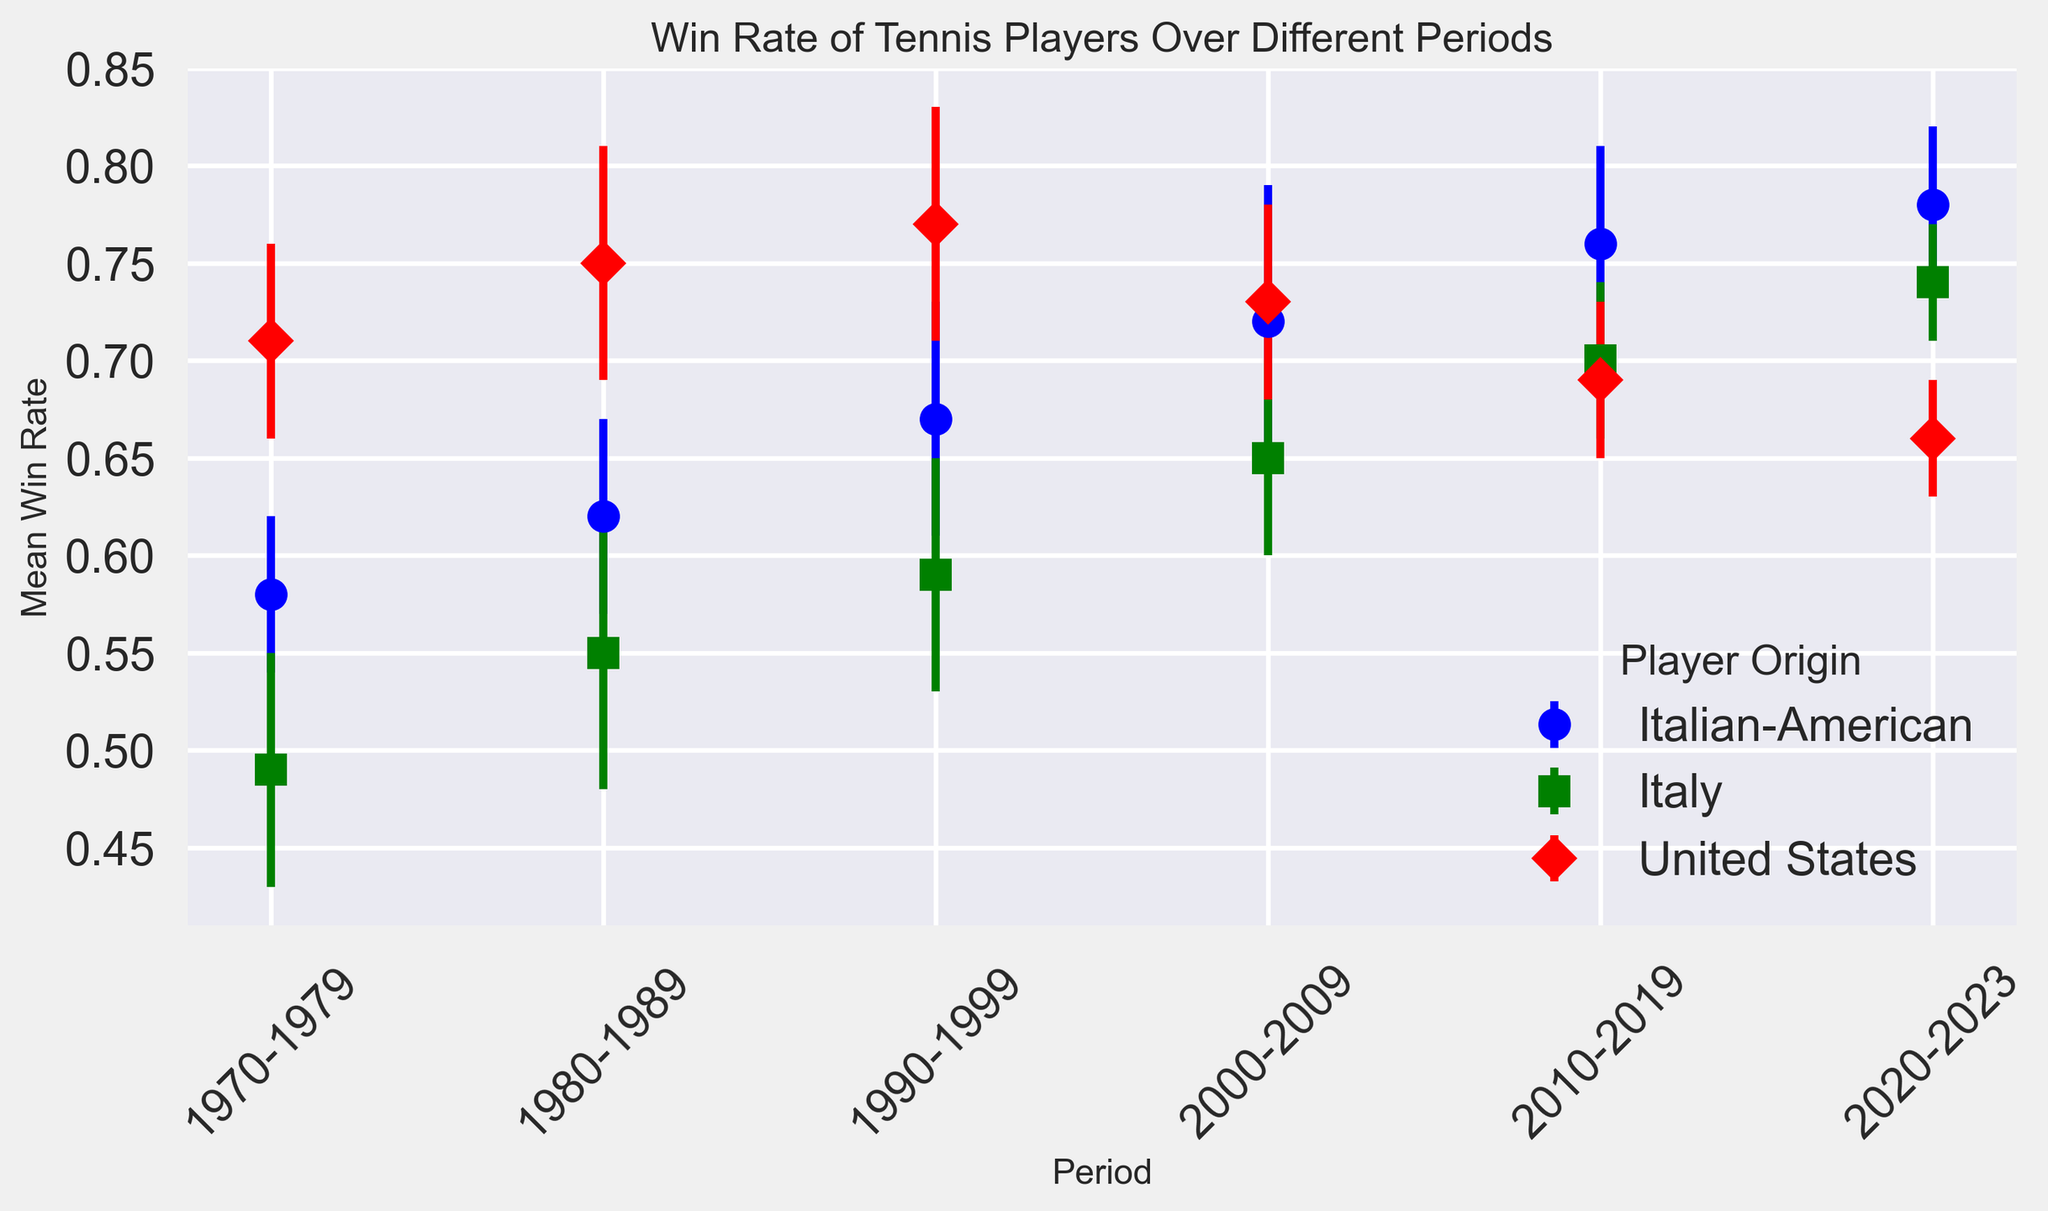Which player origin had the highest win rate in the 1970-1979 period? Look at the series of lines for each player origin and find the one that is highest in the 1970-1979 period. The United States players' line is highest at this period.
Answer: United States How did the win rate of Italian-American players change from the 1970-1979 period to the 2020-2023 period? Determine the win rate of Italian-American players in both periods and calculate the difference. The win rate increased from 0.58 to 0.78.
Answer: Increased by 0.20 Which period showed a decrease in win rate for United States players? Trace the United States players' line and identify the period where the win rate decreases. The win rate decreased between the 1990-1999 and 2000-2009 periods, and again between the 2000-2009 and 2010-2019 periods.
Answer: 2000-2009 and 2010-2019 In which period is the difference in win rate between Italian and Italian-American players the greatest? Examine the lines for Italian and Italian-American players in each period and find the period with the greatest vertical distance between them. The 2000-2009 period has the greatest difference.
Answer: 2000-2009 Compare the win rate trend of Italian and United States players from 1980-2019. Follow the lines for both origins from 1980 to 2019. Italian players show a consistent increase, while United States players show an initial increase until 1999, then a decrease.
Answer: Italians increased consistently; U.S. increased then decreased Which player origin had the smallest standard deviation in their win rate in the 2020-2023 period? Identify the standard deviations in the 2020-2023 period for all origins. Italian players have a standard deviation of 0.03, which is the smallest.
Answer: Italy 